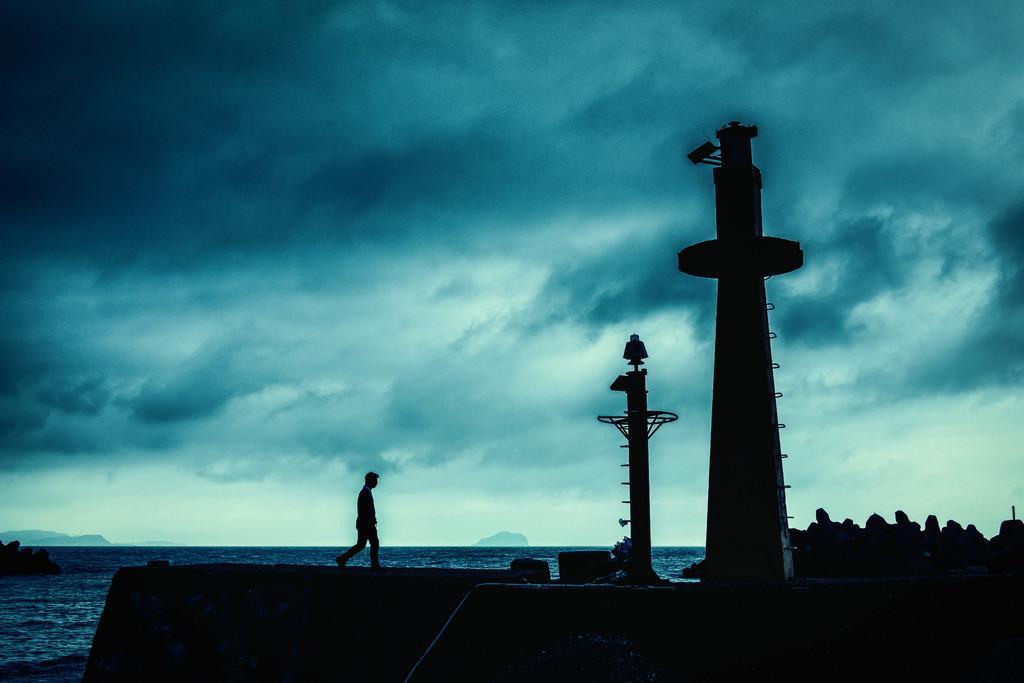In one or two sentences, can you explain what this image depicts? This picture is clicked outside. In the foreground we can see some objects. On the left there is a person seems to be walking on the ground. On the right we can see a tower and many other objects. In the background we can see the sky which is full of clouds and we can see some objects in the water body. 